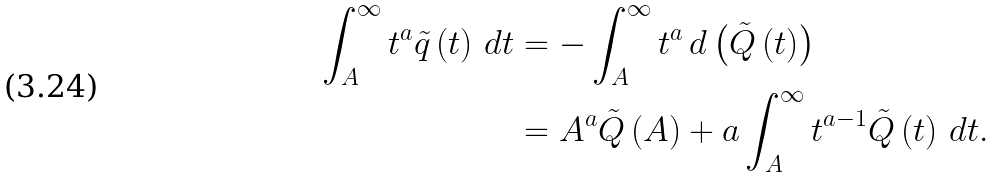<formula> <loc_0><loc_0><loc_500><loc_500>\int _ { A } ^ { \infty } t ^ { a } \tilde { q } \left ( t \right ) \, d t & = - \int _ { A } ^ { \infty } t ^ { a } \, d \left ( \tilde { Q } \left ( t \right ) \right ) \\ & = A ^ { a } \tilde { Q } \left ( A \right ) + a \int _ { A } ^ { \infty } t ^ { a - 1 } \tilde { Q } \left ( t \right ) \, d t .</formula> 